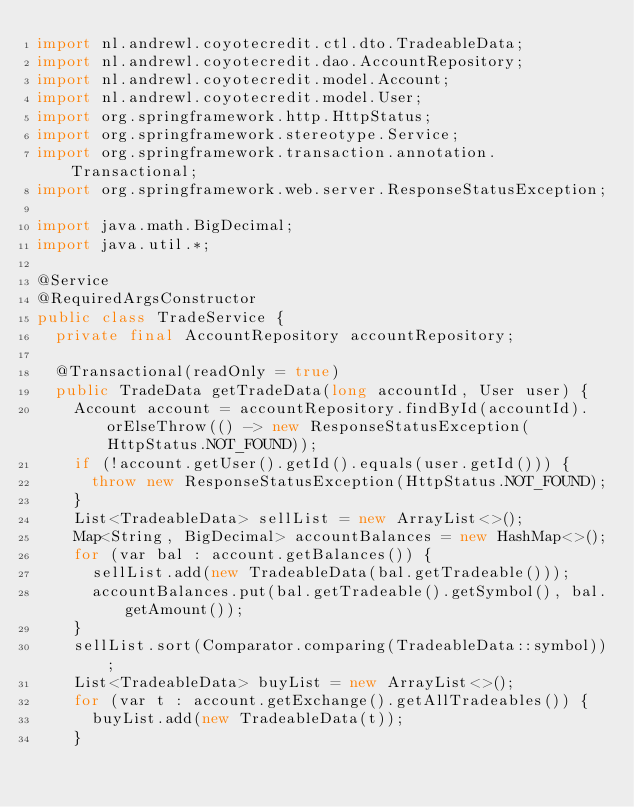Convert code to text. <code><loc_0><loc_0><loc_500><loc_500><_Java_>import nl.andrewl.coyotecredit.ctl.dto.TradeableData;
import nl.andrewl.coyotecredit.dao.AccountRepository;
import nl.andrewl.coyotecredit.model.Account;
import nl.andrewl.coyotecredit.model.User;
import org.springframework.http.HttpStatus;
import org.springframework.stereotype.Service;
import org.springframework.transaction.annotation.Transactional;
import org.springframework.web.server.ResponseStatusException;

import java.math.BigDecimal;
import java.util.*;

@Service
@RequiredArgsConstructor
public class TradeService {
	private final AccountRepository accountRepository;

	@Transactional(readOnly = true)
	public TradeData getTradeData(long accountId, User user) {
		Account account = accountRepository.findById(accountId).orElseThrow(() -> new ResponseStatusException(HttpStatus.NOT_FOUND));
		if (!account.getUser().getId().equals(user.getId())) {
			throw new ResponseStatusException(HttpStatus.NOT_FOUND);
		}
		List<TradeableData> sellList = new ArrayList<>();
		Map<String, BigDecimal> accountBalances = new HashMap<>();
		for (var bal : account.getBalances()) {
			sellList.add(new TradeableData(bal.getTradeable()));
			accountBalances.put(bal.getTradeable().getSymbol(), bal.getAmount());
		}
		sellList.sort(Comparator.comparing(TradeableData::symbol));
		List<TradeableData> buyList = new ArrayList<>();
		for (var t : account.getExchange().getAllTradeables()) {
			buyList.add(new TradeableData(t));
		}
</code> 